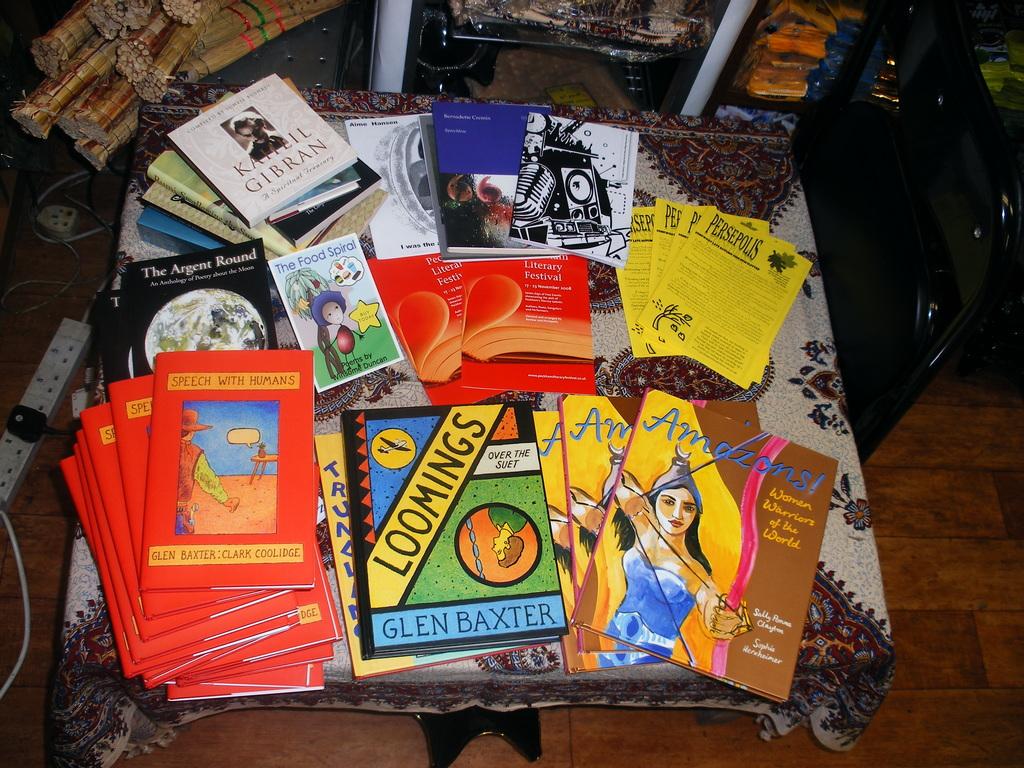What book is subtitled "under the suet?
Provide a short and direct response. Loomings. 